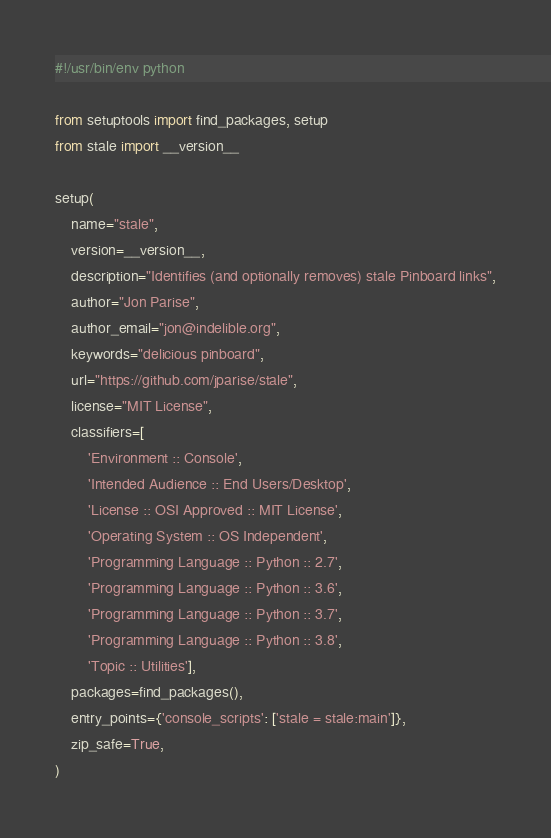<code> <loc_0><loc_0><loc_500><loc_500><_Python_>#!/usr/bin/env python

from setuptools import find_packages, setup
from stale import __version__

setup(
    name="stale",
    version=__version__,
    description="Identifies (and optionally removes) stale Pinboard links",
    author="Jon Parise",
    author_email="jon@indelible.org",
    keywords="delicious pinboard",
    url="https://github.com/jparise/stale",
    license="MIT License",
    classifiers=[
        'Environment :: Console',
        'Intended Audience :: End Users/Desktop',
        'License :: OSI Approved :: MIT License',
        'Operating System :: OS Independent',
        'Programming Language :: Python :: 2.7',
        'Programming Language :: Python :: 3.6',
        'Programming Language :: Python :: 3.7',
        'Programming Language :: Python :: 3.8',
        'Topic :: Utilities'],
    packages=find_packages(),
    entry_points={'console_scripts': ['stale = stale:main']},
    zip_safe=True,
)
</code> 